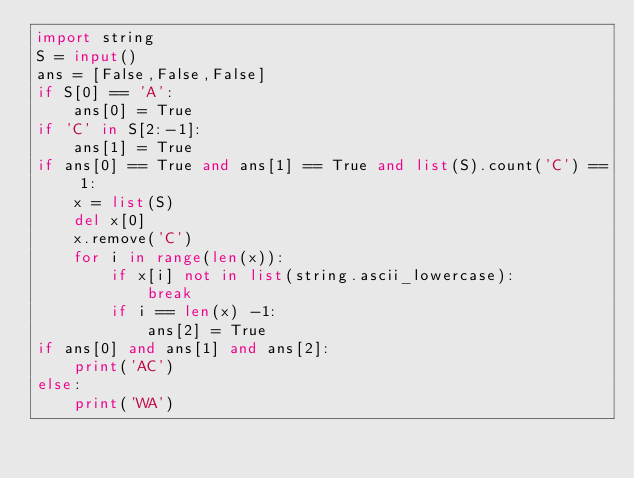<code> <loc_0><loc_0><loc_500><loc_500><_Python_>import string
S = input()
ans = [False,False,False]
if S[0] == 'A':
    ans[0] = True
if 'C' in S[2:-1]:
    ans[1] = True
if ans[0] == True and ans[1] == True and list(S).count('C') == 1:
    x = list(S)
    del x[0]
    x.remove('C')
    for i in range(len(x)):
        if x[i] not in list(string.ascii_lowercase):
            break
        if i == len(x) -1:
            ans[2] = True
if ans[0] and ans[1] and ans[2]:
    print('AC')
else:
    print('WA')</code> 